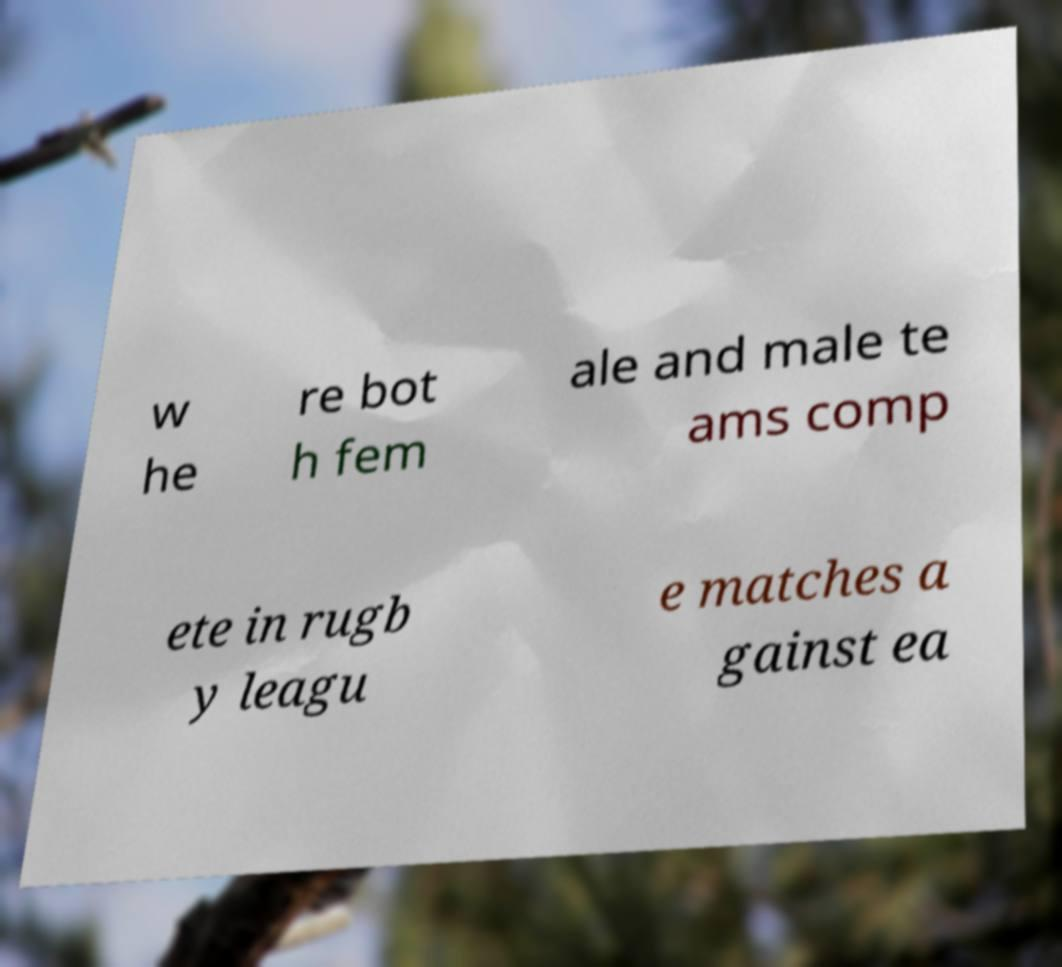Can you accurately transcribe the text from the provided image for me? w he re bot h fem ale and male te ams comp ete in rugb y leagu e matches a gainst ea 